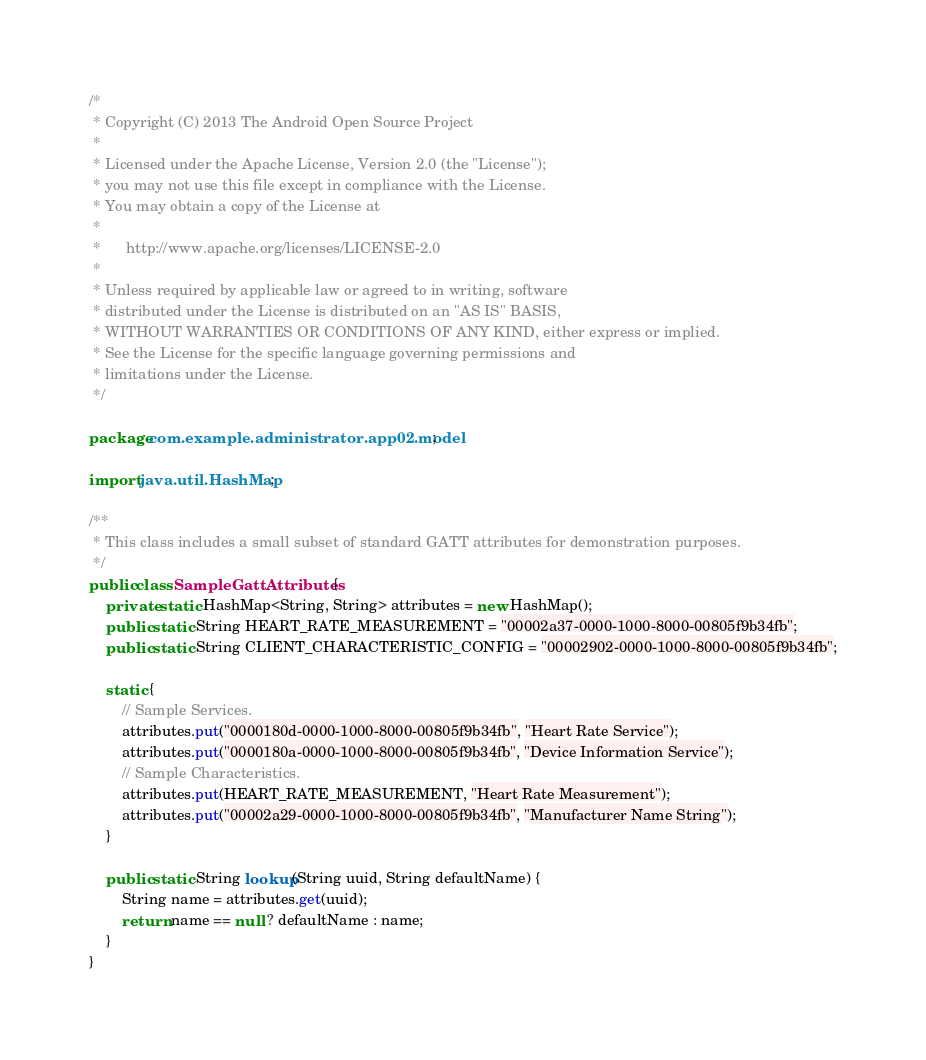<code> <loc_0><loc_0><loc_500><loc_500><_Java_>/*
 * Copyright (C) 2013 The Android Open Source Project
 *
 * Licensed under the Apache License, Version 2.0 (the "License");
 * you may not use this file except in compliance with the License.
 * You may obtain a copy of the License at
 *
 *      http://www.apache.org/licenses/LICENSE-2.0
 *
 * Unless required by applicable law or agreed to in writing, software
 * distributed under the License is distributed on an "AS IS" BASIS,
 * WITHOUT WARRANTIES OR CONDITIONS OF ANY KIND, either express or implied.
 * See the License for the specific language governing permissions and
 * limitations under the License.
 */

package com.example.administrator.app02.model;

import java.util.HashMap;

/**
 * This class includes a small subset of standard GATT attributes for demonstration purposes.
 */
public class SampleGattAttributes {
    private static HashMap<String, String> attributes = new HashMap();
    public static String HEART_RATE_MEASUREMENT = "00002a37-0000-1000-8000-00805f9b34fb";
    public static String CLIENT_CHARACTERISTIC_CONFIG = "00002902-0000-1000-8000-00805f9b34fb";

    static {
        // Sample Services.
        attributes.put("0000180d-0000-1000-8000-00805f9b34fb", "Heart Rate Service");
        attributes.put("0000180a-0000-1000-8000-00805f9b34fb", "Device Information Service");
        // Sample Characteristics.
        attributes.put(HEART_RATE_MEASUREMENT, "Heart Rate Measurement");
        attributes.put("00002a29-0000-1000-8000-00805f9b34fb", "Manufacturer Name String");
    }

    public static String lookup(String uuid, String defaultName) {
        String name = attributes.get(uuid);
        return name == null ? defaultName : name;
    }
}</code> 